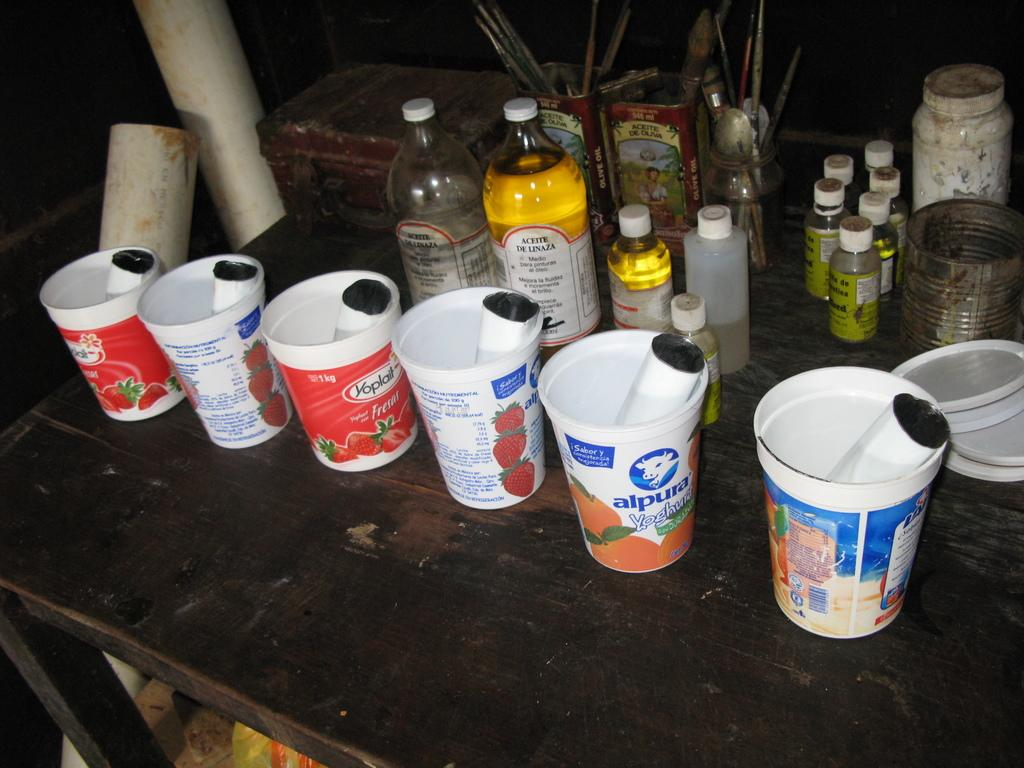Provide a one-sentence caption for the provided image. an alpura cup that is on top of the desk. 